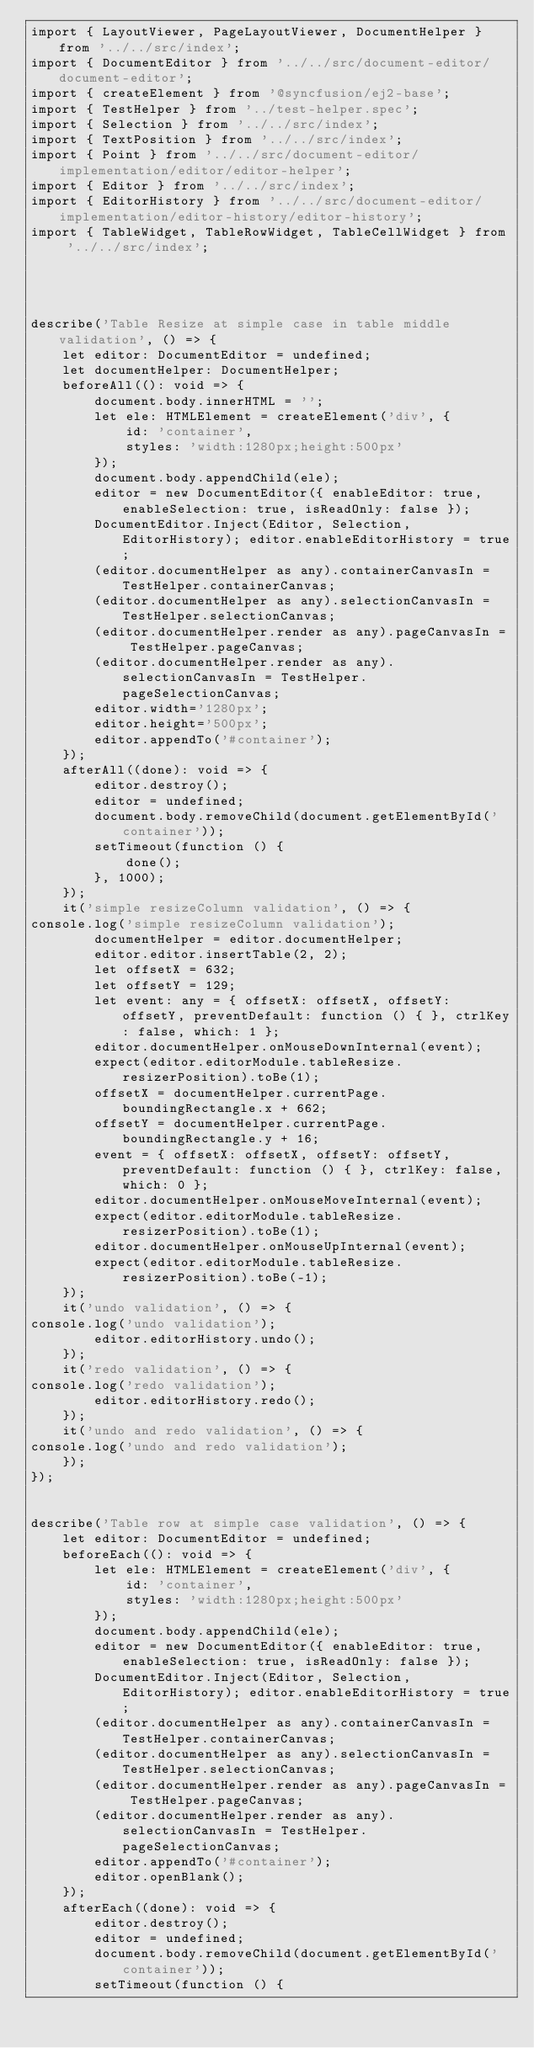Convert code to text. <code><loc_0><loc_0><loc_500><loc_500><_TypeScript_>import { LayoutViewer, PageLayoutViewer, DocumentHelper } from '../../src/index';
import { DocumentEditor } from '../../src/document-editor/document-editor';
import { createElement } from '@syncfusion/ej2-base';
import { TestHelper } from '../test-helper.spec';
import { Selection } from '../../src/index';
import { TextPosition } from '../../src/index';
import { Point } from '../../src/document-editor/implementation/editor/editor-helper';
import { Editor } from '../../src/index';
import { EditorHistory } from '../../src/document-editor/implementation/editor-history/editor-history';
import { TableWidget, TableRowWidget, TableCellWidget } from '../../src/index';




describe('Table Resize at simple case in table middle validation', () => {
    let editor: DocumentEditor = undefined;
    let documentHelper: DocumentHelper;
    beforeAll((): void => {
        document.body.innerHTML = '';
        let ele: HTMLElement = createElement('div', {
            id: 'container',
            styles: 'width:1280px;height:500px'
        });
        document.body.appendChild(ele);
        editor = new DocumentEditor({ enableEditor: true, enableSelection: true, isReadOnly: false });
        DocumentEditor.Inject(Editor, Selection, EditorHistory); editor.enableEditorHistory = true;
        (editor.documentHelper as any).containerCanvasIn = TestHelper.containerCanvas;
        (editor.documentHelper as any).selectionCanvasIn = TestHelper.selectionCanvas;
        (editor.documentHelper.render as any).pageCanvasIn = TestHelper.pageCanvas;
        (editor.documentHelper.render as any).selectionCanvasIn = TestHelper.pageSelectionCanvas;
        editor.width='1280px';
        editor.height='500px';
        editor.appendTo('#container');
    });
    afterAll((done): void => {
        editor.destroy();
        editor = undefined;
        document.body.removeChild(document.getElementById('container'));
        setTimeout(function () {
            done();
        }, 1000);
    });
    it('simple resizeColumn validation', () => {
console.log('simple resizeColumn validation');
        documentHelper = editor.documentHelper;
        editor.editor.insertTable(2, 2);
        let offsetX = 632;
        let offsetY = 129;
        let event: any = { offsetX: offsetX, offsetY: offsetY, preventDefault: function () { }, ctrlKey: false, which: 1 };
        editor.documentHelper.onMouseDownInternal(event);
        expect(editor.editorModule.tableResize.resizerPosition).toBe(1);
        offsetX = documentHelper.currentPage.boundingRectangle.x + 662;
        offsetY = documentHelper.currentPage.boundingRectangle.y + 16;
        event = { offsetX: offsetX, offsetY: offsetY, preventDefault: function () { }, ctrlKey: false, which: 0 };
        editor.documentHelper.onMouseMoveInternal(event);
        expect(editor.editorModule.tableResize.resizerPosition).toBe(1);
        editor.documentHelper.onMouseUpInternal(event);
        expect(editor.editorModule.tableResize.resizerPosition).toBe(-1);
    });
    it('undo validation', () => {
console.log('undo validation');
        editor.editorHistory.undo();
    });
    it('redo validation', () => {
console.log('redo validation');
        editor.editorHistory.redo();
    });
    it('undo and redo validation', () => {
console.log('undo and redo validation');
    });
});


describe('Table row at simple case validation', () => {
    let editor: DocumentEditor = undefined;
    beforeEach((): void => {
        let ele: HTMLElement = createElement('div', {
            id: 'container',
            styles: 'width:1280px;height:500px'
        });
        document.body.appendChild(ele);
        editor = new DocumentEditor({ enableEditor: true, enableSelection: true, isReadOnly: false });
        DocumentEditor.Inject(Editor, Selection, EditorHistory); editor.enableEditorHistory = true;
        (editor.documentHelper as any).containerCanvasIn = TestHelper.containerCanvas;
        (editor.documentHelper as any).selectionCanvasIn = TestHelper.selectionCanvas;
        (editor.documentHelper.render as any).pageCanvasIn = TestHelper.pageCanvas;
        (editor.documentHelper.render as any).selectionCanvasIn = TestHelper.pageSelectionCanvas;
        editor.appendTo('#container');
        editor.openBlank();
    });
    afterEach((done): void => {
        editor.destroy();
        editor = undefined;
        document.body.removeChild(document.getElementById('container'));
        setTimeout(function () {</code> 